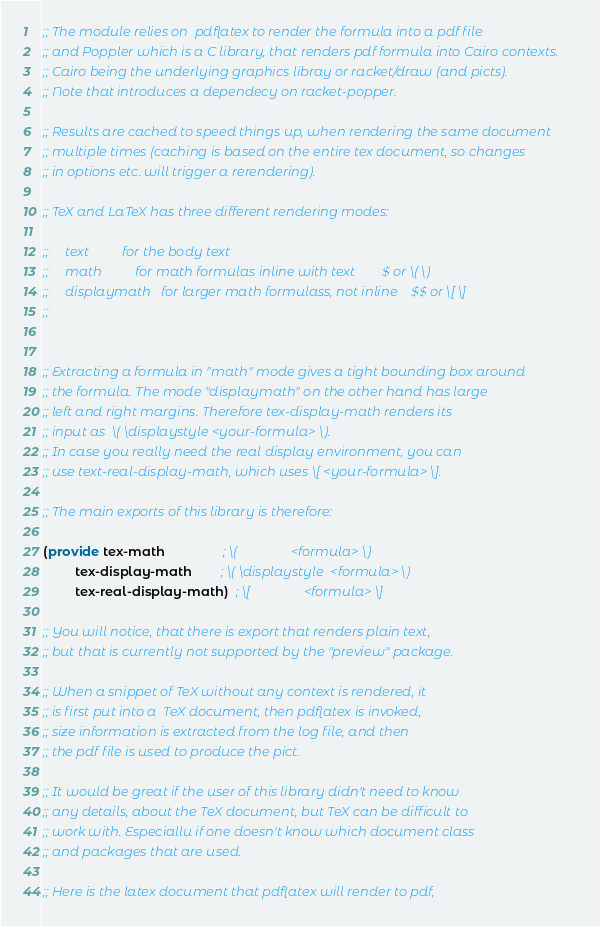<code> <loc_0><loc_0><loc_500><loc_500><_Racket_>;; The module relies on  pdflatex to render the formula into a pdf file
;; and Poppler which is a C library, that renders pdf formula into Cairo contexts.
;; Cairo being the underlying graphics libray or racket/draw (and picts).
;; Note that introduces a dependecy on racket-popper.

;; Results are cached to speed things up, when rendering the same document
;; multiple times (caching is based on the entire tex document, so changes
;; in options etc. will trigger a rerendering).

;; TeX and LaTeX has three different rendering modes:

;;     text          for the body text
;;     math          for math formulas inline with text        $ or \( \)
;;     displaymath   for larger math formulass, not inline    $$ or \[ \]
;;     


;; Extracting a formula in "math" mode gives a tight bounding box around
;; the formula. The mode "displaymath" on the other hand has large
;; left and right margins. Therefore tex-display-math renders its
;; input as  \( \displaystyle <your-formula> \).
;; In case you really need the real display environment, you can
;; use text-real-display-math, which uses \[ <your-formula> \].

;; The main exports of this library is therefore:

(provide tex-math                ; \(                <formula> \)
         tex-display-math        ; \( \displaystyle  <formula> \)
         tex-real-display-math)  ; \[                <formula> \]

;; You will notice, that there is export that renders plain text,
;; but that is currently not supported by the "preview" package.

;; When a snippet of TeX without any context is rendered, it
;; is first put into a  TeX document, then pdflatex is invoked,
;; size information is extracted from the log file, and then
;; the pdf file is used to produce the pict.

;; It would be great if the user of this library didn't need to know
;; any details, about the TeX document, but TeX can be difficult to
;; work with. Especiallu if one doesn't know which document class
;; and packages that are used.

;; Here is the latex document that pdflatex will render to pdf,</code> 